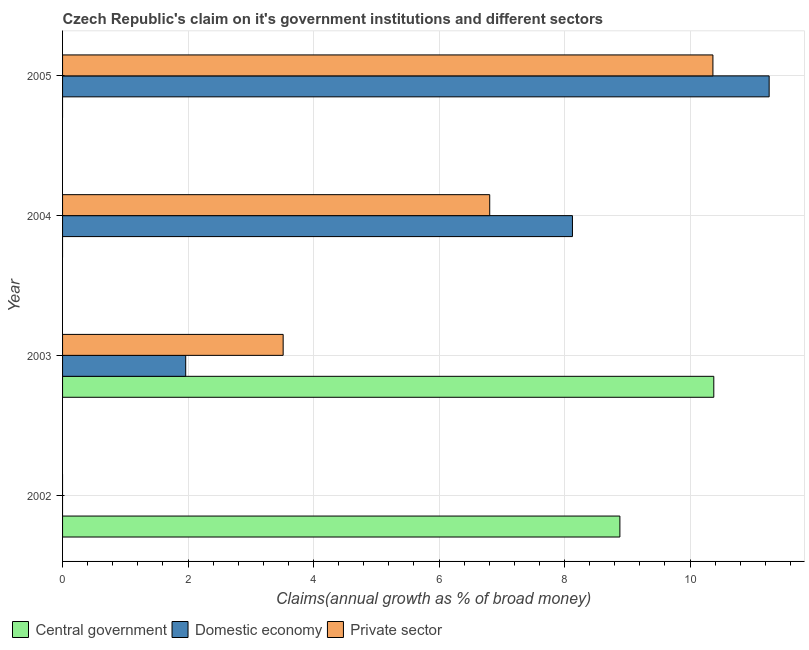How many different coloured bars are there?
Your response must be concise. 3. Are the number of bars per tick equal to the number of legend labels?
Ensure brevity in your answer.  No. How many bars are there on the 2nd tick from the top?
Offer a terse response. 2. In how many cases, is the number of bars for a given year not equal to the number of legend labels?
Give a very brief answer. 3. What is the percentage of claim on the private sector in 2003?
Make the answer very short. 3.52. Across all years, what is the maximum percentage of claim on the private sector?
Offer a very short reply. 10.37. Across all years, what is the minimum percentage of claim on the central government?
Your response must be concise. 0. In which year was the percentage of claim on the private sector maximum?
Provide a succinct answer. 2005. What is the total percentage of claim on the private sector in the graph?
Offer a terse response. 20.69. What is the difference between the percentage of claim on the private sector in 2003 and that in 2004?
Your answer should be compact. -3.29. What is the difference between the percentage of claim on the central government in 2005 and the percentage of claim on the private sector in 2003?
Your response must be concise. -3.52. What is the average percentage of claim on the central government per year?
Give a very brief answer. 4.82. In the year 2005, what is the difference between the percentage of claim on the private sector and percentage of claim on the domestic economy?
Offer a terse response. -0.9. In how many years, is the percentage of claim on the private sector greater than 2.8 %?
Provide a short and direct response. 3. What is the ratio of the percentage of claim on the domestic economy in 2003 to that in 2004?
Keep it short and to the point. 0.24. Is the percentage of claim on the domestic economy in 2003 less than that in 2005?
Your answer should be compact. Yes. What is the difference between the highest and the second highest percentage of claim on the private sector?
Your answer should be very brief. 3.56. What is the difference between the highest and the lowest percentage of claim on the private sector?
Offer a terse response. 10.37. In how many years, is the percentage of claim on the central government greater than the average percentage of claim on the central government taken over all years?
Your answer should be compact. 2. Is the sum of the percentage of claim on the private sector in 2003 and 2005 greater than the maximum percentage of claim on the central government across all years?
Give a very brief answer. Yes. How many bars are there?
Your answer should be compact. 8. Are the values on the major ticks of X-axis written in scientific E-notation?
Give a very brief answer. No. Does the graph contain any zero values?
Give a very brief answer. Yes. How many legend labels are there?
Ensure brevity in your answer.  3. What is the title of the graph?
Ensure brevity in your answer.  Czech Republic's claim on it's government institutions and different sectors. What is the label or title of the X-axis?
Provide a succinct answer. Claims(annual growth as % of broad money). What is the label or title of the Y-axis?
Your answer should be very brief. Year. What is the Claims(annual growth as % of broad money) of Central government in 2002?
Offer a very short reply. 8.88. What is the Claims(annual growth as % of broad money) in Domestic economy in 2002?
Provide a succinct answer. 0. What is the Claims(annual growth as % of broad money) in Private sector in 2002?
Offer a terse response. 0. What is the Claims(annual growth as % of broad money) in Central government in 2003?
Your answer should be very brief. 10.38. What is the Claims(annual growth as % of broad money) of Domestic economy in 2003?
Your answer should be very brief. 1.96. What is the Claims(annual growth as % of broad money) of Private sector in 2003?
Keep it short and to the point. 3.52. What is the Claims(annual growth as % of broad money) of Central government in 2004?
Ensure brevity in your answer.  0. What is the Claims(annual growth as % of broad money) of Domestic economy in 2004?
Provide a succinct answer. 8.13. What is the Claims(annual growth as % of broad money) in Private sector in 2004?
Offer a very short reply. 6.81. What is the Claims(annual growth as % of broad money) in Domestic economy in 2005?
Keep it short and to the point. 11.26. What is the Claims(annual growth as % of broad money) in Private sector in 2005?
Your response must be concise. 10.37. Across all years, what is the maximum Claims(annual growth as % of broad money) in Central government?
Ensure brevity in your answer.  10.38. Across all years, what is the maximum Claims(annual growth as % of broad money) of Domestic economy?
Give a very brief answer. 11.26. Across all years, what is the maximum Claims(annual growth as % of broad money) in Private sector?
Make the answer very short. 10.37. Across all years, what is the minimum Claims(annual growth as % of broad money) in Private sector?
Your response must be concise. 0. What is the total Claims(annual growth as % of broad money) in Central government in the graph?
Offer a very short reply. 19.26. What is the total Claims(annual growth as % of broad money) in Domestic economy in the graph?
Make the answer very short. 21.35. What is the total Claims(annual growth as % of broad money) in Private sector in the graph?
Ensure brevity in your answer.  20.69. What is the difference between the Claims(annual growth as % of broad money) in Central government in 2002 and that in 2003?
Give a very brief answer. -1.5. What is the difference between the Claims(annual growth as % of broad money) in Domestic economy in 2003 and that in 2004?
Give a very brief answer. -6.16. What is the difference between the Claims(annual growth as % of broad money) in Private sector in 2003 and that in 2004?
Your response must be concise. -3.29. What is the difference between the Claims(annual growth as % of broad money) in Domestic economy in 2003 and that in 2005?
Offer a terse response. -9.3. What is the difference between the Claims(annual growth as % of broad money) of Private sector in 2003 and that in 2005?
Provide a short and direct response. -6.85. What is the difference between the Claims(annual growth as % of broad money) of Domestic economy in 2004 and that in 2005?
Provide a short and direct response. -3.14. What is the difference between the Claims(annual growth as % of broad money) in Private sector in 2004 and that in 2005?
Offer a very short reply. -3.56. What is the difference between the Claims(annual growth as % of broad money) of Central government in 2002 and the Claims(annual growth as % of broad money) of Domestic economy in 2003?
Provide a short and direct response. 6.92. What is the difference between the Claims(annual growth as % of broad money) in Central government in 2002 and the Claims(annual growth as % of broad money) in Private sector in 2003?
Provide a short and direct response. 5.37. What is the difference between the Claims(annual growth as % of broad money) in Central government in 2002 and the Claims(annual growth as % of broad money) in Domestic economy in 2004?
Ensure brevity in your answer.  0.76. What is the difference between the Claims(annual growth as % of broad money) of Central government in 2002 and the Claims(annual growth as % of broad money) of Private sector in 2004?
Give a very brief answer. 2.07. What is the difference between the Claims(annual growth as % of broad money) in Central government in 2002 and the Claims(annual growth as % of broad money) in Domestic economy in 2005?
Make the answer very short. -2.38. What is the difference between the Claims(annual growth as % of broad money) of Central government in 2002 and the Claims(annual growth as % of broad money) of Private sector in 2005?
Keep it short and to the point. -1.48. What is the difference between the Claims(annual growth as % of broad money) of Central government in 2003 and the Claims(annual growth as % of broad money) of Domestic economy in 2004?
Your response must be concise. 2.25. What is the difference between the Claims(annual growth as % of broad money) of Central government in 2003 and the Claims(annual growth as % of broad money) of Private sector in 2004?
Keep it short and to the point. 3.57. What is the difference between the Claims(annual growth as % of broad money) of Domestic economy in 2003 and the Claims(annual growth as % of broad money) of Private sector in 2004?
Offer a very short reply. -4.85. What is the difference between the Claims(annual growth as % of broad money) in Central government in 2003 and the Claims(annual growth as % of broad money) in Domestic economy in 2005?
Provide a succinct answer. -0.88. What is the difference between the Claims(annual growth as % of broad money) in Central government in 2003 and the Claims(annual growth as % of broad money) in Private sector in 2005?
Give a very brief answer. 0.01. What is the difference between the Claims(annual growth as % of broad money) of Domestic economy in 2003 and the Claims(annual growth as % of broad money) of Private sector in 2005?
Give a very brief answer. -8.4. What is the difference between the Claims(annual growth as % of broad money) in Domestic economy in 2004 and the Claims(annual growth as % of broad money) in Private sector in 2005?
Give a very brief answer. -2.24. What is the average Claims(annual growth as % of broad money) of Central government per year?
Offer a very short reply. 4.82. What is the average Claims(annual growth as % of broad money) of Domestic economy per year?
Offer a terse response. 5.34. What is the average Claims(annual growth as % of broad money) of Private sector per year?
Offer a very short reply. 5.17. In the year 2003, what is the difference between the Claims(annual growth as % of broad money) in Central government and Claims(annual growth as % of broad money) in Domestic economy?
Your response must be concise. 8.42. In the year 2003, what is the difference between the Claims(annual growth as % of broad money) in Central government and Claims(annual growth as % of broad money) in Private sector?
Offer a very short reply. 6.86. In the year 2003, what is the difference between the Claims(annual growth as % of broad money) of Domestic economy and Claims(annual growth as % of broad money) of Private sector?
Make the answer very short. -1.55. In the year 2004, what is the difference between the Claims(annual growth as % of broad money) of Domestic economy and Claims(annual growth as % of broad money) of Private sector?
Your response must be concise. 1.32. In the year 2005, what is the difference between the Claims(annual growth as % of broad money) in Domestic economy and Claims(annual growth as % of broad money) in Private sector?
Give a very brief answer. 0.9. What is the ratio of the Claims(annual growth as % of broad money) in Central government in 2002 to that in 2003?
Provide a short and direct response. 0.86. What is the ratio of the Claims(annual growth as % of broad money) of Domestic economy in 2003 to that in 2004?
Your answer should be very brief. 0.24. What is the ratio of the Claims(annual growth as % of broad money) of Private sector in 2003 to that in 2004?
Keep it short and to the point. 0.52. What is the ratio of the Claims(annual growth as % of broad money) of Domestic economy in 2003 to that in 2005?
Provide a short and direct response. 0.17. What is the ratio of the Claims(annual growth as % of broad money) of Private sector in 2003 to that in 2005?
Offer a very short reply. 0.34. What is the ratio of the Claims(annual growth as % of broad money) in Domestic economy in 2004 to that in 2005?
Offer a very short reply. 0.72. What is the ratio of the Claims(annual growth as % of broad money) in Private sector in 2004 to that in 2005?
Your response must be concise. 0.66. What is the difference between the highest and the second highest Claims(annual growth as % of broad money) of Domestic economy?
Give a very brief answer. 3.14. What is the difference between the highest and the second highest Claims(annual growth as % of broad money) of Private sector?
Offer a terse response. 3.56. What is the difference between the highest and the lowest Claims(annual growth as % of broad money) in Central government?
Offer a very short reply. 10.38. What is the difference between the highest and the lowest Claims(annual growth as % of broad money) in Domestic economy?
Make the answer very short. 11.26. What is the difference between the highest and the lowest Claims(annual growth as % of broad money) of Private sector?
Ensure brevity in your answer.  10.37. 